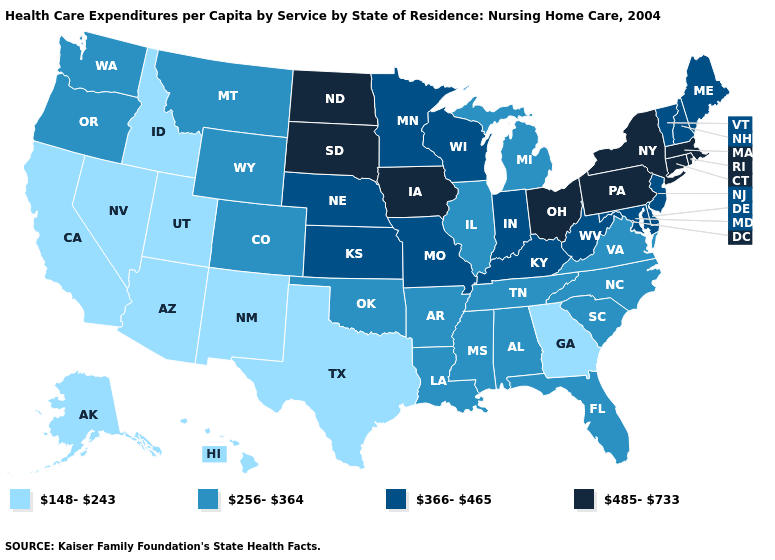Does Arkansas have the highest value in the South?
Keep it brief. No. Does Arkansas have the highest value in the USA?
Be succinct. No. What is the lowest value in the USA?
Short answer required. 148-243. Name the states that have a value in the range 366-465?
Write a very short answer. Delaware, Indiana, Kansas, Kentucky, Maine, Maryland, Minnesota, Missouri, Nebraska, New Hampshire, New Jersey, Vermont, West Virginia, Wisconsin. Does the first symbol in the legend represent the smallest category?
Quick response, please. Yes. What is the value of Tennessee?
Be succinct. 256-364. Name the states that have a value in the range 485-733?
Quick response, please. Connecticut, Iowa, Massachusetts, New York, North Dakota, Ohio, Pennsylvania, Rhode Island, South Dakota. What is the lowest value in states that border Utah?
Write a very short answer. 148-243. Name the states that have a value in the range 148-243?
Write a very short answer. Alaska, Arizona, California, Georgia, Hawaii, Idaho, Nevada, New Mexico, Texas, Utah. What is the value of Mississippi?
Quick response, please. 256-364. Name the states that have a value in the range 485-733?
Short answer required. Connecticut, Iowa, Massachusetts, New York, North Dakota, Ohio, Pennsylvania, Rhode Island, South Dakota. Among the states that border Florida , which have the lowest value?
Answer briefly. Georgia. Does Louisiana have the highest value in the USA?
Answer briefly. No. Which states have the lowest value in the Northeast?
Give a very brief answer. Maine, New Hampshire, New Jersey, Vermont. What is the value of New Mexico?
Short answer required. 148-243. 